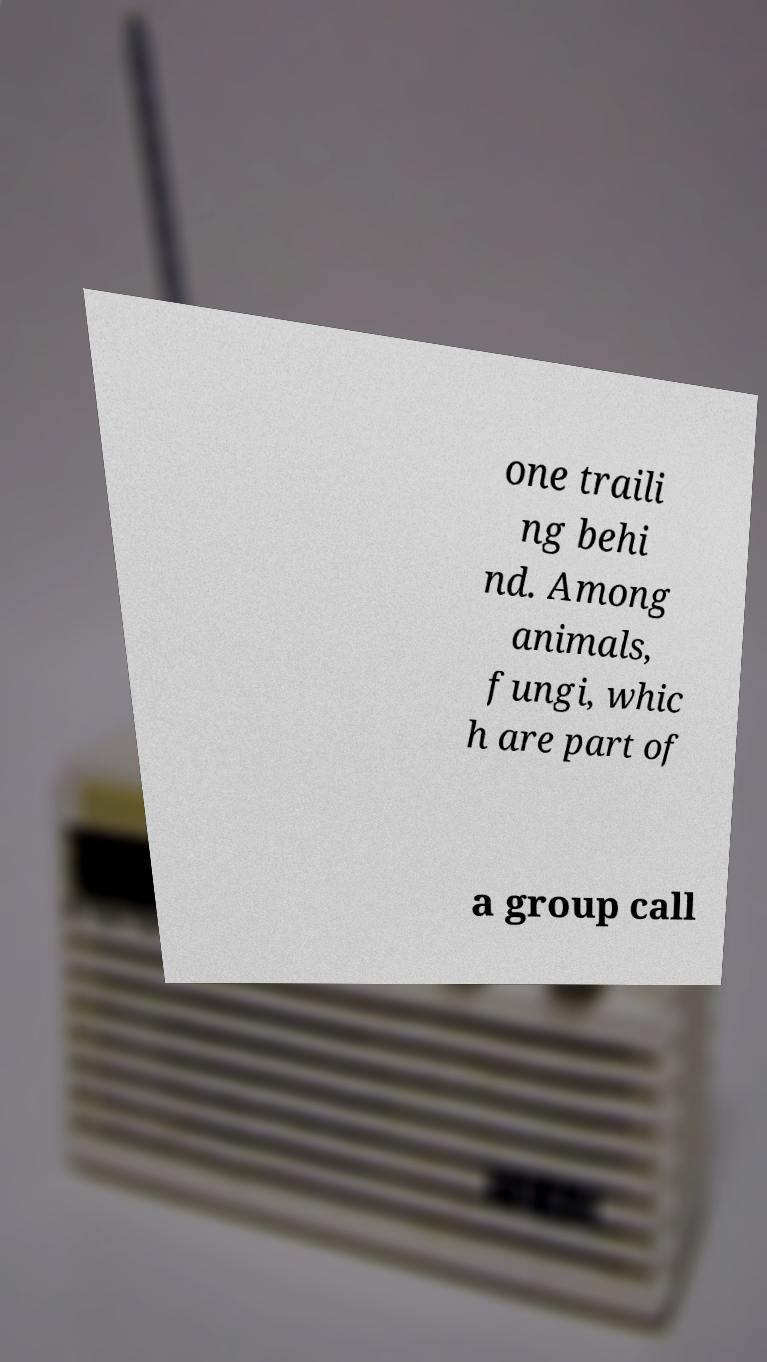Please identify and transcribe the text found in this image. one traili ng behi nd. Among animals, fungi, whic h are part of a group call 